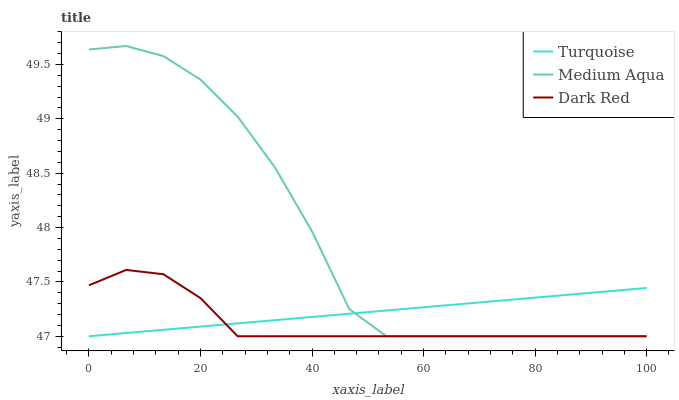Does Dark Red have the minimum area under the curve?
Answer yes or no. Yes. Does Medium Aqua have the maximum area under the curve?
Answer yes or no. Yes. Does Turquoise have the minimum area under the curve?
Answer yes or no. No. Does Turquoise have the maximum area under the curve?
Answer yes or no. No. Is Turquoise the smoothest?
Answer yes or no. Yes. Is Medium Aqua the roughest?
Answer yes or no. Yes. Is Medium Aqua the smoothest?
Answer yes or no. No. Is Turquoise the roughest?
Answer yes or no. No. Does Dark Red have the lowest value?
Answer yes or no. Yes. Does Medium Aqua have the highest value?
Answer yes or no. Yes. Does Turquoise have the highest value?
Answer yes or no. No. Does Turquoise intersect Dark Red?
Answer yes or no. Yes. Is Turquoise less than Dark Red?
Answer yes or no. No. Is Turquoise greater than Dark Red?
Answer yes or no. No. 